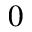Convert formula to latex. <formula><loc_0><loc_0><loc_500><loc_500>0</formula> 